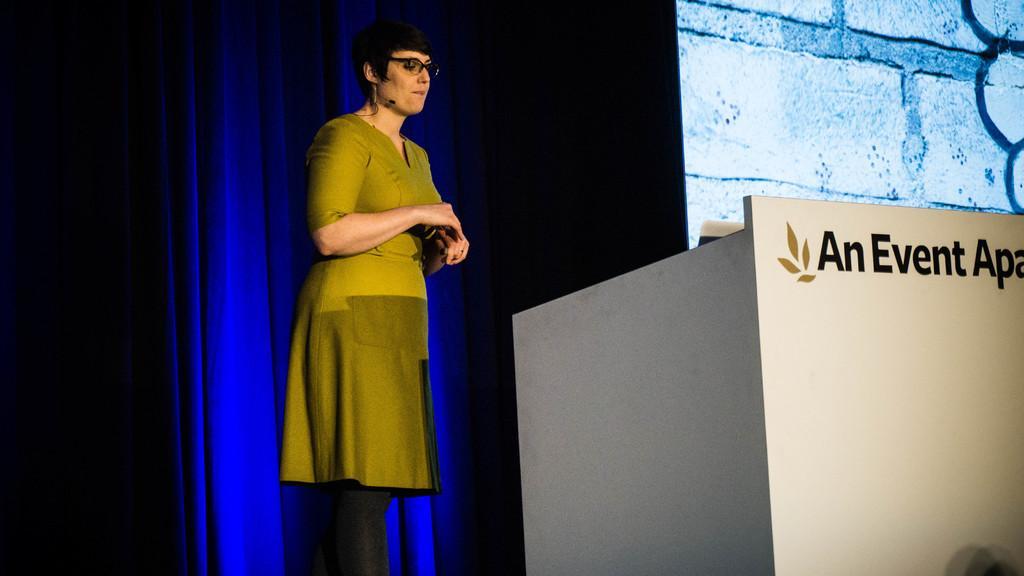Describe this image in one or two sentences. In this image I can see a person standing. There is a curtain, screen and there is a podium. 